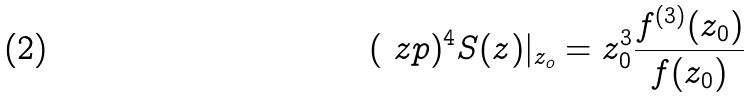<formula> <loc_0><loc_0><loc_500><loc_500>( \ z p ) ^ { 4 } S ( z ) | _ { z _ { o } } = z _ { 0 } ^ { 3 } \frac { f ^ { ( 3 ) } ( z _ { 0 } ) } { f ( z _ { 0 } ) }</formula> 